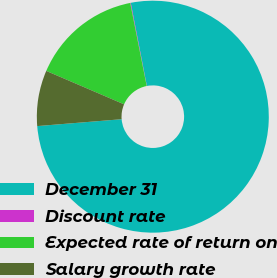Convert chart. <chart><loc_0><loc_0><loc_500><loc_500><pie_chart><fcel>December 31<fcel>Discount rate<fcel>Expected rate of return on<fcel>Salary growth rate<nl><fcel>76.76%<fcel>0.08%<fcel>15.42%<fcel>7.75%<nl></chart> 